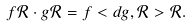Convert formula to latex. <formula><loc_0><loc_0><loc_500><loc_500>f \mathcal { R } \cdot g \mathcal { R } = f < d g , \mathcal { R } > \mathcal { R } .</formula> 